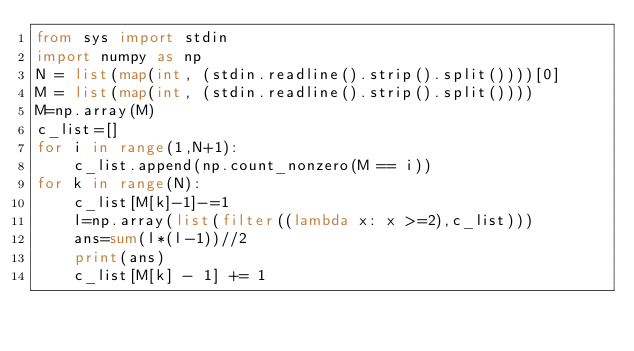Convert code to text. <code><loc_0><loc_0><loc_500><loc_500><_Python_>from sys import stdin
import numpy as np
N = list(map(int, (stdin.readline().strip().split())))[0]
M = list(map(int, (stdin.readline().strip().split())))
M=np.array(M)
c_list=[]
for i in range(1,N+1):
    c_list.append(np.count_nonzero(M == i))
for k in range(N):
    c_list[M[k]-1]-=1
    l=np.array(list(filter((lambda x: x >=2),c_list)))
    ans=sum(l*(l-1))//2
    print(ans)
    c_list[M[k] - 1] += 1</code> 